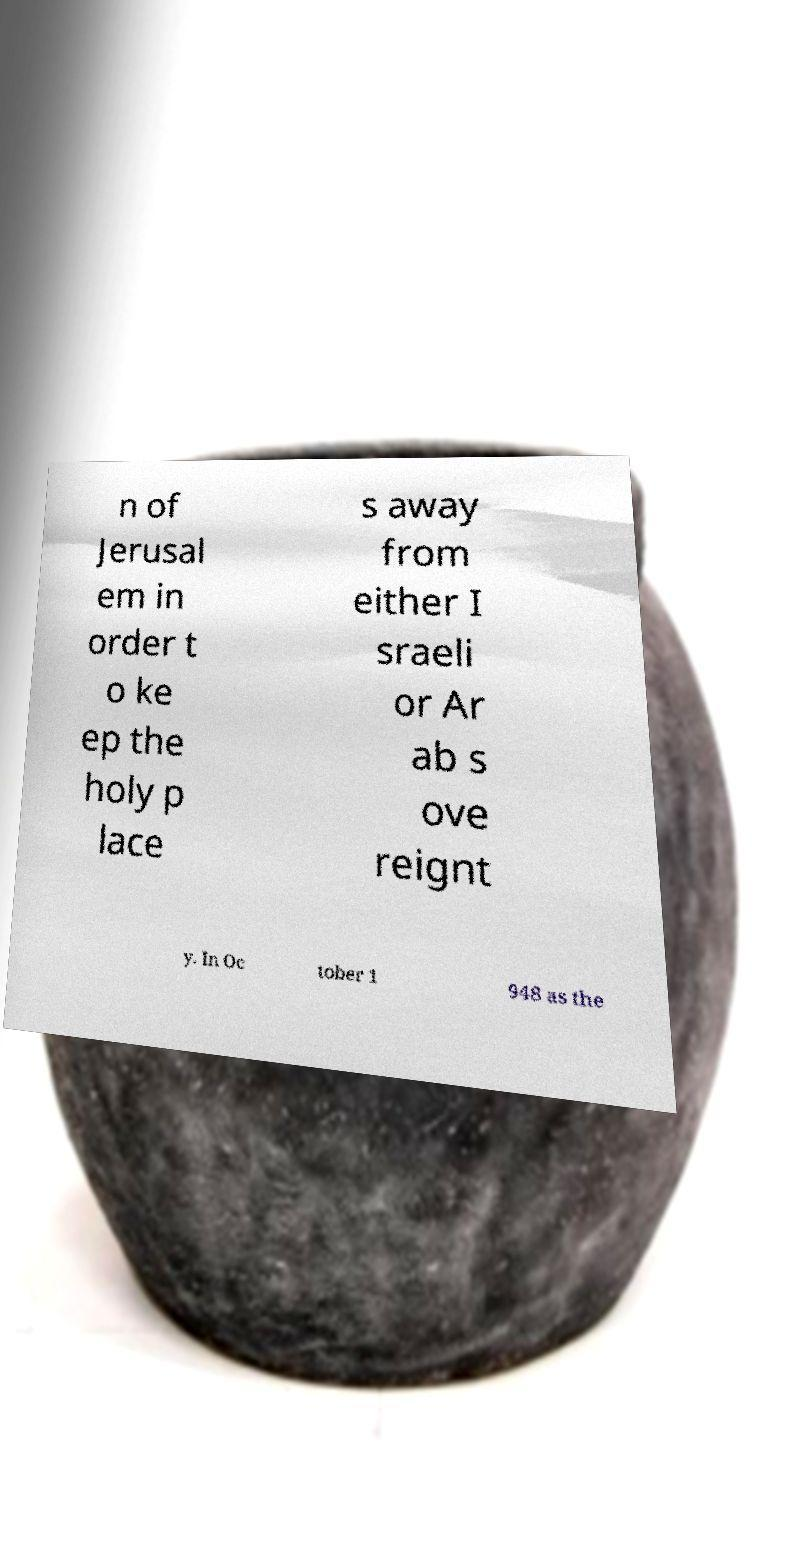Can you accurately transcribe the text from the provided image for me? n of Jerusal em in order t o ke ep the holy p lace s away from either I sraeli or Ar ab s ove reignt y. In Oc tober 1 948 as the 